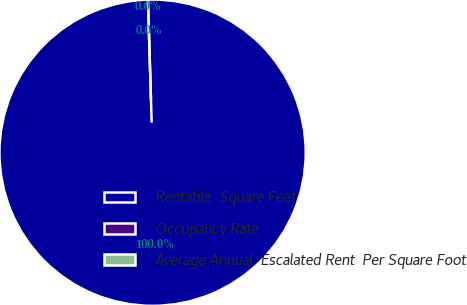Convert chart. <chart><loc_0><loc_0><loc_500><loc_500><pie_chart><fcel>Rentable  Square Feet<fcel>Occupancy Rate<fcel>Average Annual  Escalated Rent  Per Square Foot<nl><fcel>100.0%<fcel>0.0%<fcel>0.0%<nl></chart> 